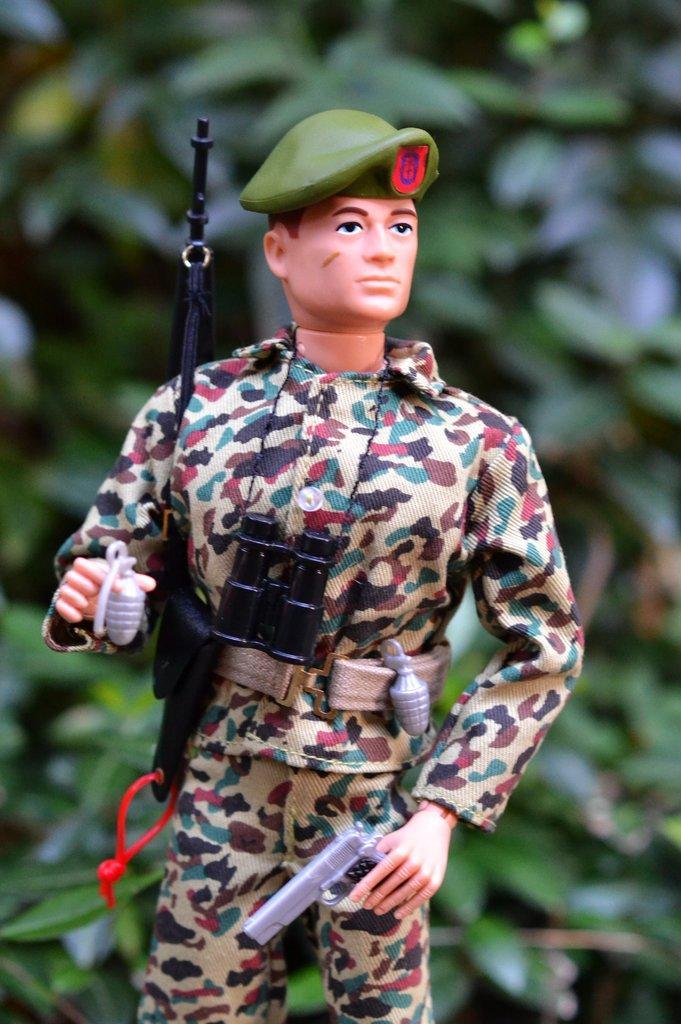How would you summarize this image in a sentence or two? In this image we can see the toy of a man. 